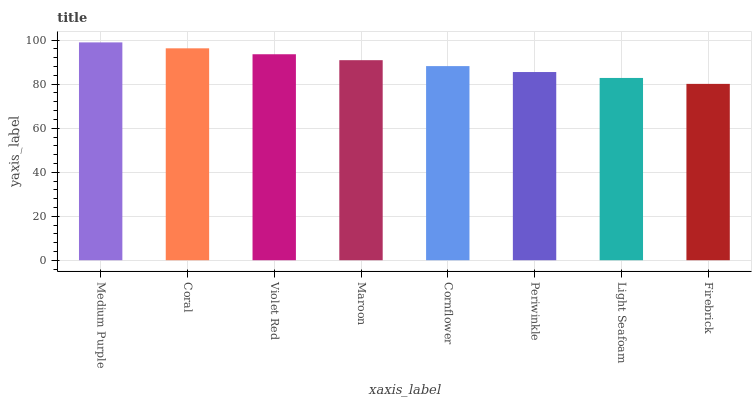Is Firebrick the minimum?
Answer yes or no. Yes. Is Medium Purple the maximum?
Answer yes or no. Yes. Is Coral the minimum?
Answer yes or no. No. Is Coral the maximum?
Answer yes or no. No. Is Medium Purple greater than Coral?
Answer yes or no. Yes. Is Coral less than Medium Purple?
Answer yes or no. Yes. Is Coral greater than Medium Purple?
Answer yes or no. No. Is Medium Purple less than Coral?
Answer yes or no. No. Is Maroon the high median?
Answer yes or no. Yes. Is Cornflower the low median?
Answer yes or no. Yes. Is Cornflower the high median?
Answer yes or no. No. Is Periwinkle the low median?
Answer yes or no. No. 